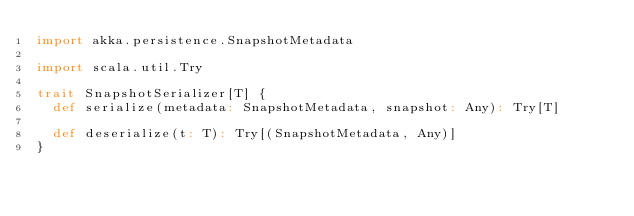<code> <loc_0><loc_0><loc_500><loc_500><_Scala_>import akka.persistence.SnapshotMetadata

import scala.util.Try

trait SnapshotSerializer[T] {
  def serialize(metadata: SnapshotMetadata, snapshot: Any): Try[T]

  def deserialize(t: T): Try[(SnapshotMetadata, Any)]
}
</code> 